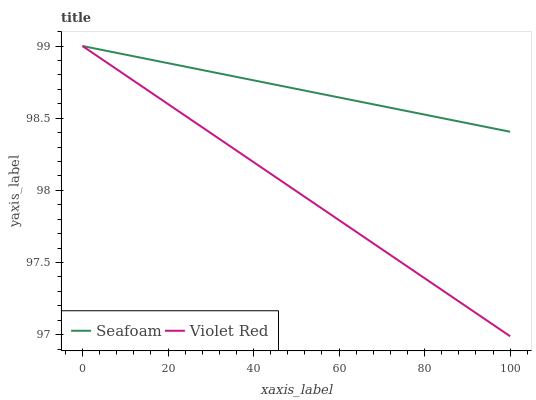Does Violet Red have the minimum area under the curve?
Answer yes or no. Yes. Does Seafoam have the maximum area under the curve?
Answer yes or no. Yes. Does Seafoam have the minimum area under the curve?
Answer yes or no. No. Is Violet Red the smoothest?
Answer yes or no. Yes. Is Seafoam the roughest?
Answer yes or no. Yes. Is Seafoam the smoothest?
Answer yes or no. No. Does Violet Red have the lowest value?
Answer yes or no. Yes. Does Seafoam have the lowest value?
Answer yes or no. No. Does Seafoam have the highest value?
Answer yes or no. Yes. Does Violet Red intersect Seafoam?
Answer yes or no. Yes. Is Violet Red less than Seafoam?
Answer yes or no. No. Is Violet Red greater than Seafoam?
Answer yes or no. No. 